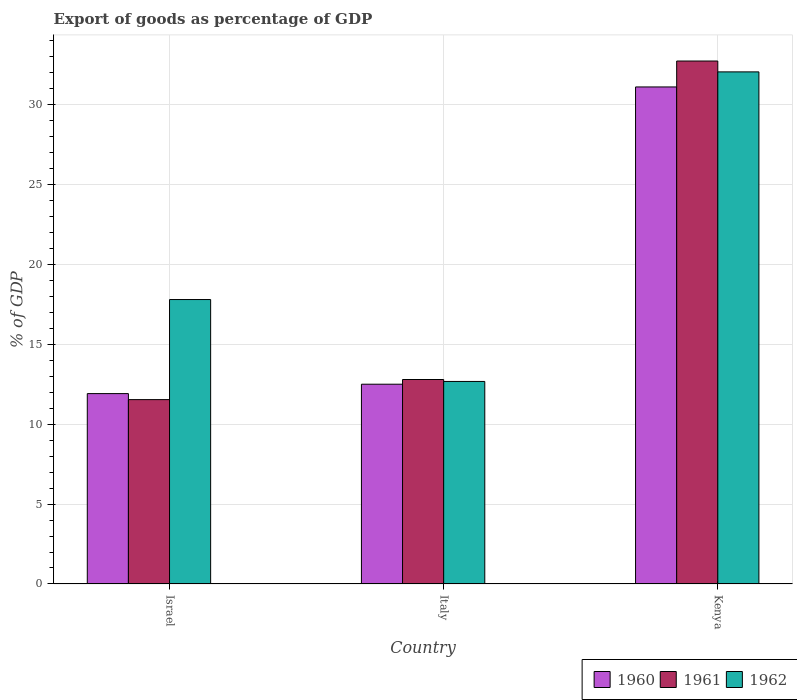Are the number of bars per tick equal to the number of legend labels?
Your response must be concise. Yes. Are the number of bars on each tick of the X-axis equal?
Make the answer very short. Yes. What is the label of the 1st group of bars from the left?
Offer a terse response. Israel. What is the export of goods as percentage of GDP in 1960 in Italy?
Provide a short and direct response. 12.5. Across all countries, what is the maximum export of goods as percentage of GDP in 1962?
Your answer should be compact. 32.04. Across all countries, what is the minimum export of goods as percentage of GDP in 1962?
Offer a very short reply. 12.67. In which country was the export of goods as percentage of GDP in 1961 maximum?
Keep it short and to the point. Kenya. What is the total export of goods as percentage of GDP in 1962 in the graph?
Provide a short and direct response. 62.5. What is the difference between the export of goods as percentage of GDP in 1962 in Israel and that in Italy?
Give a very brief answer. 5.12. What is the difference between the export of goods as percentage of GDP in 1961 in Kenya and the export of goods as percentage of GDP in 1962 in Israel?
Offer a very short reply. 14.92. What is the average export of goods as percentage of GDP in 1960 per country?
Provide a short and direct response. 18.5. What is the difference between the export of goods as percentage of GDP of/in 1961 and export of goods as percentage of GDP of/in 1960 in Israel?
Make the answer very short. -0.38. What is the ratio of the export of goods as percentage of GDP in 1960 in Israel to that in Kenya?
Your answer should be very brief. 0.38. Is the export of goods as percentage of GDP in 1960 in Israel less than that in Italy?
Your answer should be very brief. Yes. Is the difference between the export of goods as percentage of GDP in 1961 in Israel and Italy greater than the difference between the export of goods as percentage of GDP in 1960 in Israel and Italy?
Make the answer very short. No. What is the difference between the highest and the second highest export of goods as percentage of GDP in 1961?
Give a very brief answer. 21.18. What is the difference between the highest and the lowest export of goods as percentage of GDP in 1960?
Make the answer very short. 19.19. What does the 2nd bar from the left in Italy represents?
Your answer should be very brief. 1961. What does the 2nd bar from the right in Italy represents?
Your answer should be compact. 1961. Are all the bars in the graph horizontal?
Your answer should be very brief. No. How many countries are there in the graph?
Offer a terse response. 3. Are the values on the major ticks of Y-axis written in scientific E-notation?
Make the answer very short. No. Where does the legend appear in the graph?
Ensure brevity in your answer.  Bottom right. How are the legend labels stacked?
Give a very brief answer. Horizontal. What is the title of the graph?
Provide a succinct answer. Export of goods as percentage of GDP. Does "2001" appear as one of the legend labels in the graph?
Make the answer very short. No. What is the label or title of the Y-axis?
Give a very brief answer. % of GDP. What is the % of GDP of 1960 in Israel?
Provide a short and direct response. 11.91. What is the % of GDP in 1961 in Israel?
Your response must be concise. 11.53. What is the % of GDP in 1962 in Israel?
Make the answer very short. 17.8. What is the % of GDP of 1960 in Italy?
Make the answer very short. 12.5. What is the % of GDP of 1961 in Italy?
Give a very brief answer. 12.79. What is the % of GDP of 1962 in Italy?
Your answer should be very brief. 12.67. What is the % of GDP of 1960 in Kenya?
Your answer should be very brief. 31.1. What is the % of GDP in 1961 in Kenya?
Provide a short and direct response. 32.72. What is the % of GDP of 1962 in Kenya?
Your answer should be very brief. 32.04. Across all countries, what is the maximum % of GDP of 1960?
Ensure brevity in your answer.  31.1. Across all countries, what is the maximum % of GDP of 1961?
Offer a very short reply. 32.72. Across all countries, what is the maximum % of GDP in 1962?
Offer a terse response. 32.04. Across all countries, what is the minimum % of GDP in 1960?
Keep it short and to the point. 11.91. Across all countries, what is the minimum % of GDP in 1961?
Your answer should be compact. 11.53. Across all countries, what is the minimum % of GDP of 1962?
Provide a succinct answer. 12.67. What is the total % of GDP in 1960 in the graph?
Ensure brevity in your answer.  55.5. What is the total % of GDP in 1961 in the graph?
Ensure brevity in your answer.  57.04. What is the total % of GDP of 1962 in the graph?
Keep it short and to the point. 62.5. What is the difference between the % of GDP in 1960 in Israel and that in Italy?
Ensure brevity in your answer.  -0.59. What is the difference between the % of GDP in 1961 in Israel and that in Italy?
Provide a short and direct response. -1.26. What is the difference between the % of GDP of 1962 in Israel and that in Italy?
Keep it short and to the point. 5.12. What is the difference between the % of GDP of 1960 in Israel and that in Kenya?
Offer a very short reply. -19.18. What is the difference between the % of GDP in 1961 in Israel and that in Kenya?
Offer a terse response. -21.18. What is the difference between the % of GDP in 1962 in Israel and that in Kenya?
Make the answer very short. -14.24. What is the difference between the % of GDP in 1960 in Italy and that in Kenya?
Keep it short and to the point. -18.6. What is the difference between the % of GDP in 1961 in Italy and that in Kenya?
Ensure brevity in your answer.  -19.92. What is the difference between the % of GDP of 1962 in Italy and that in Kenya?
Your answer should be very brief. -19.37. What is the difference between the % of GDP of 1960 in Israel and the % of GDP of 1961 in Italy?
Your response must be concise. -0.88. What is the difference between the % of GDP of 1960 in Israel and the % of GDP of 1962 in Italy?
Your response must be concise. -0.76. What is the difference between the % of GDP of 1961 in Israel and the % of GDP of 1962 in Italy?
Offer a terse response. -1.14. What is the difference between the % of GDP of 1960 in Israel and the % of GDP of 1961 in Kenya?
Offer a terse response. -20.81. What is the difference between the % of GDP of 1960 in Israel and the % of GDP of 1962 in Kenya?
Keep it short and to the point. -20.13. What is the difference between the % of GDP of 1961 in Israel and the % of GDP of 1962 in Kenya?
Ensure brevity in your answer.  -20.5. What is the difference between the % of GDP of 1960 in Italy and the % of GDP of 1961 in Kenya?
Your answer should be compact. -20.22. What is the difference between the % of GDP of 1960 in Italy and the % of GDP of 1962 in Kenya?
Your answer should be very brief. -19.54. What is the difference between the % of GDP of 1961 in Italy and the % of GDP of 1962 in Kenya?
Provide a succinct answer. -19.25. What is the average % of GDP of 1960 per country?
Ensure brevity in your answer.  18.5. What is the average % of GDP in 1961 per country?
Offer a terse response. 19.01. What is the average % of GDP of 1962 per country?
Give a very brief answer. 20.83. What is the difference between the % of GDP in 1960 and % of GDP in 1961 in Israel?
Your answer should be compact. 0.38. What is the difference between the % of GDP of 1960 and % of GDP of 1962 in Israel?
Offer a terse response. -5.88. What is the difference between the % of GDP of 1961 and % of GDP of 1962 in Israel?
Your answer should be very brief. -6.26. What is the difference between the % of GDP in 1960 and % of GDP in 1961 in Italy?
Keep it short and to the point. -0.29. What is the difference between the % of GDP in 1960 and % of GDP in 1962 in Italy?
Provide a succinct answer. -0.17. What is the difference between the % of GDP of 1961 and % of GDP of 1962 in Italy?
Ensure brevity in your answer.  0.12. What is the difference between the % of GDP of 1960 and % of GDP of 1961 in Kenya?
Provide a succinct answer. -1.62. What is the difference between the % of GDP of 1960 and % of GDP of 1962 in Kenya?
Your answer should be compact. -0.94. What is the difference between the % of GDP of 1961 and % of GDP of 1962 in Kenya?
Your answer should be very brief. 0.68. What is the ratio of the % of GDP of 1960 in Israel to that in Italy?
Offer a very short reply. 0.95. What is the ratio of the % of GDP in 1961 in Israel to that in Italy?
Offer a very short reply. 0.9. What is the ratio of the % of GDP in 1962 in Israel to that in Italy?
Provide a succinct answer. 1.4. What is the ratio of the % of GDP in 1960 in Israel to that in Kenya?
Keep it short and to the point. 0.38. What is the ratio of the % of GDP of 1961 in Israel to that in Kenya?
Your answer should be compact. 0.35. What is the ratio of the % of GDP in 1962 in Israel to that in Kenya?
Your response must be concise. 0.56. What is the ratio of the % of GDP in 1960 in Italy to that in Kenya?
Your answer should be very brief. 0.4. What is the ratio of the % of GDP of 1961 in Italy to that in Kenya?
Your response must be concise. 0.39. What is the ratio of the % of GDP of 1962 in Italy to that in Kenya?
Provide a succinct answer. 0.4. What is the difference between the highest and the second highest % of GDP in 1960?
Offer a very short reply. 18.6. What is the difference between the highest and the second highest % of GDP of 1961?
Keep it short and to the point. 19.92. What is the difference between the highest and the second highest % of GDP of 1962?
Make the answer very short. 14.24. What is the difference between the highest and the lowest % of GDP of 1960?
Keep it short and to the point. 19.18. What is the difference between the highest and the lowest % of GDP of 1961?
Your answer should be compact. 21.18. What is the difference between the highest and the lowest % of GDP of 1962?
Provide a succinct answer. 19.37. 